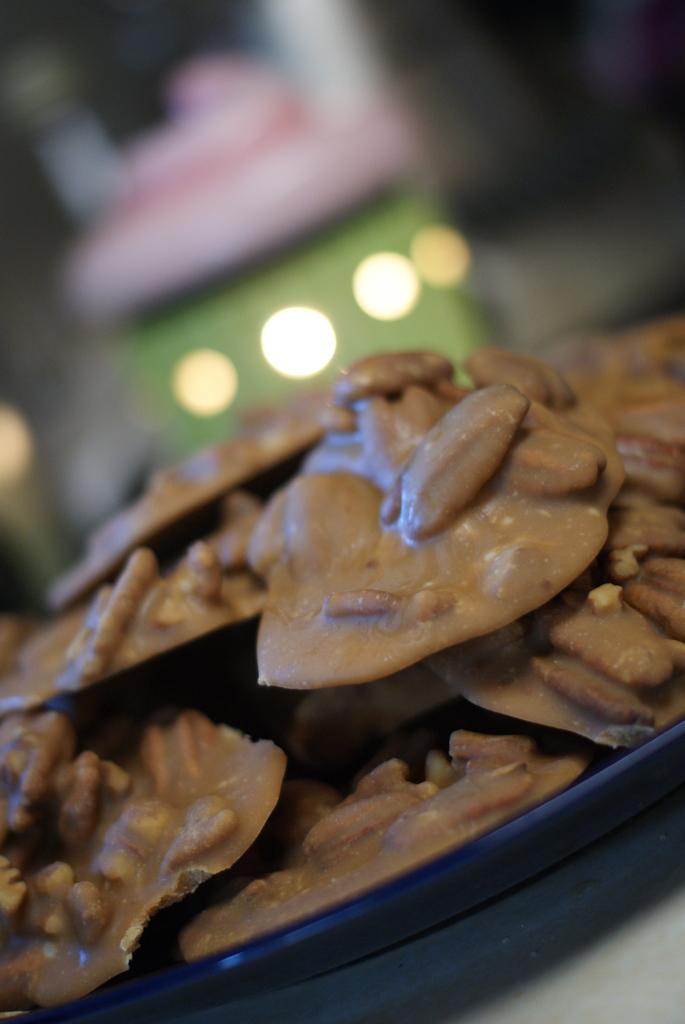In one or two sentences, can you explain what this image depicts? In this image we can see some food item placed on the surface. 